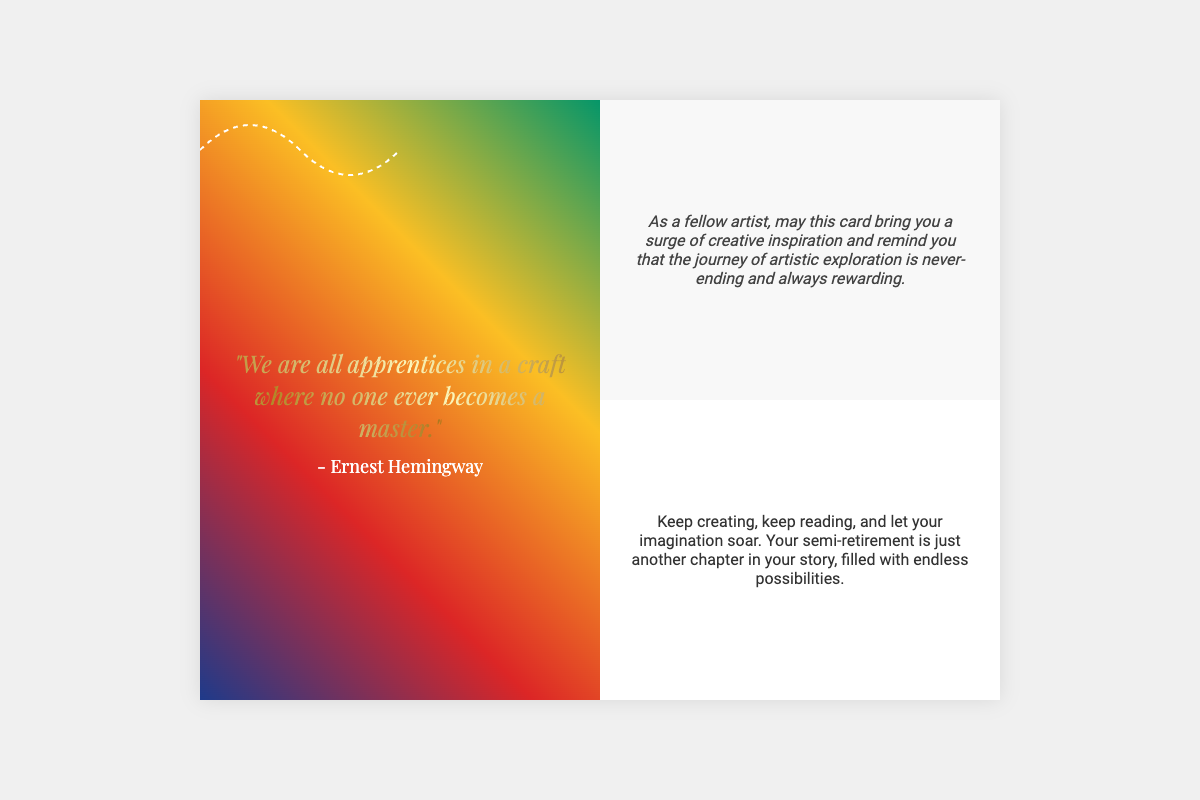What quote is featured on the card? The quote is displayed prominently in the front cover, stating, "We are all apprentices in a craft where no one ever becomes a master."
Answer: "We are all apprentices in a craft where no one ever becomes a master." Who is the author of the quote? The author’s name is included beneath the quote on the front cover of the card.
Answer: - Ernest Hemingway What colors are used in the gradient on the front cover? The gradient features several colors listed by their specific codes: #1E3A8A, #DC2626, #FBBF24, #059669.
Answer: #1E3A8A, #DC2626, #FBBF24, #059669 What is the primary theme of the card? The card conveys a message of artistic inspiration and the continuous journey of artistic exploration, as detailed in the inside text.
Answer: Artistic inspiration How many sections are there inside the card? The inside of the card consists of two distinct sections for personalized messages.
Answer: Two What is the visual effect applied to the flowing lines? The flowing lines have a specific animation that makes them appear to move continuously across the card.
Answer: Animation What style is the text in the inside left section? The text in the left-hand section uses italics and is styled to evoke a sense of creativity.
Answer: Italic What message is conveyed about semi-retirement? The inside text encourages creativity and perceives semi-retirement as a new opportunity for inspiration and exploration.
Answer: Endless possibilities 